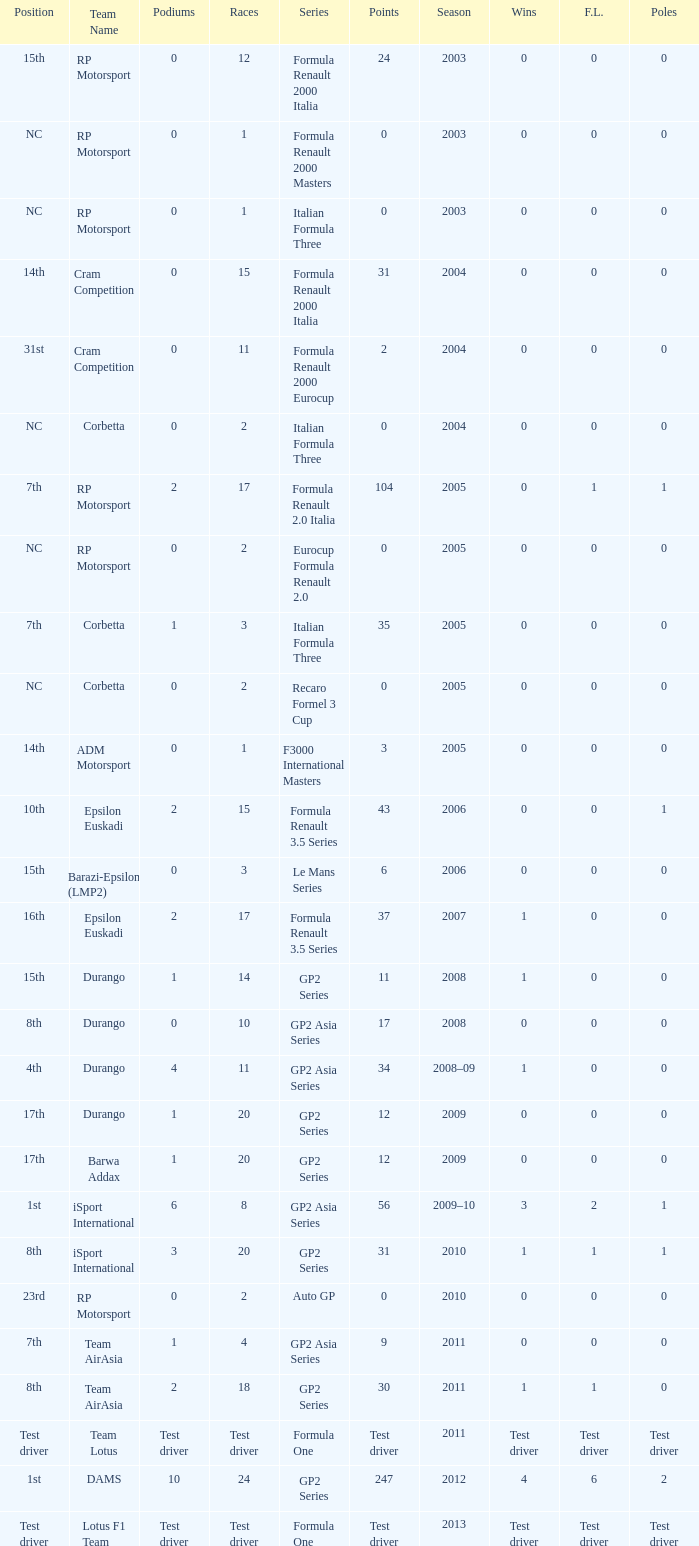What is the number of podiums with 0 wins and 6 points? 0.0. 